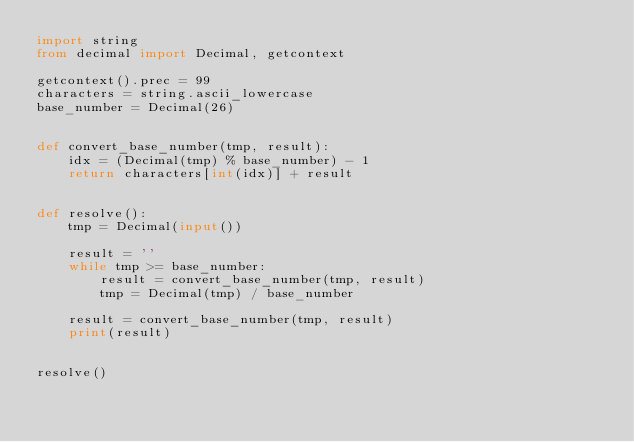<code> <loc_0><loc_0><loc_500><loc_500><_Python_>import string
from decimal import Decimal, getcontext

getcontext().prec = 99
characters = string.ascii_lowercase
base_number = Decimal(26)


def convert_base_number(tmp, result):
    idx = (Decimal(tmp) % base_number) - 1
    return characters[int(idx)] + result


def resolve():
    tmp = Decimal(input())

    result = ''
    while tmp >= base_number:
        result = convert_base_number(tmp, result)
        tmp = Decimal(tmp) / base_number

    result = convert_base_number(tmp, result)
    print(result)


resolve()</code> 